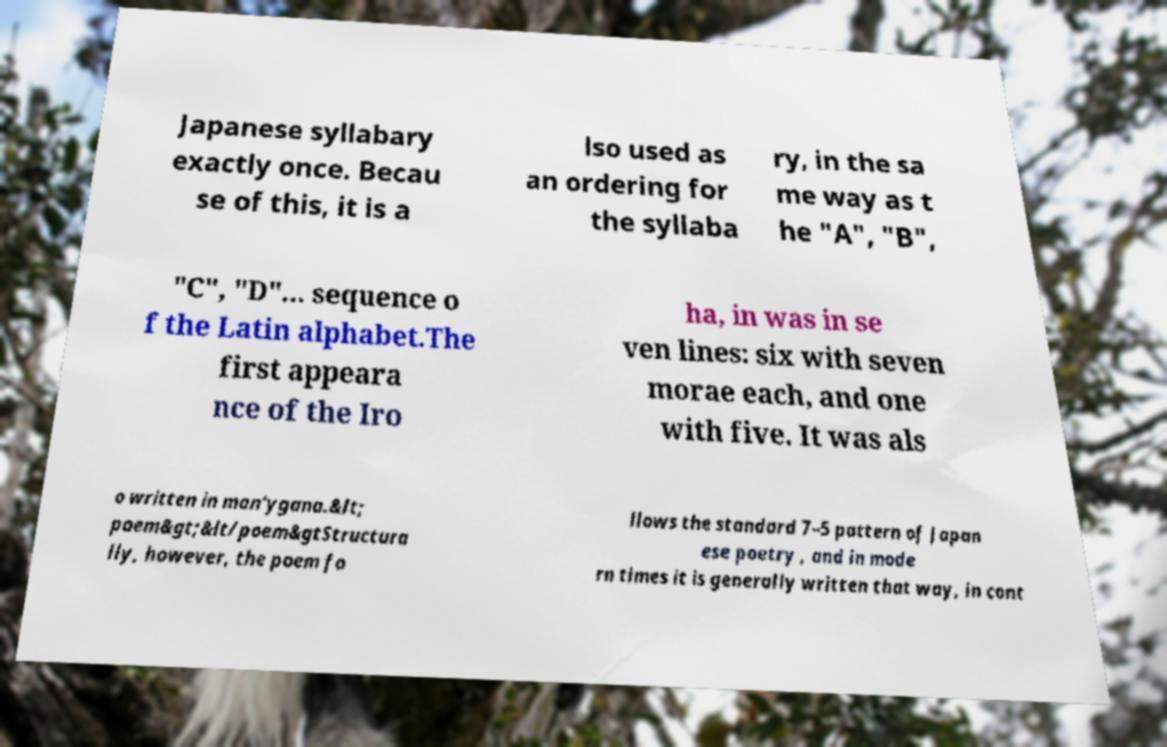Can you read and provide the text displayed in the image?This photo seems to have some interesting text. Can you extract and type it out for me? Japanese syllabary exactly once. Becau se of this, it is a lso used as an ordering for the syllaba ry, in the sa me way as t he "A", "B", "C", "D"... sequence o f the Latin alphabet.The first appeara nce of the Iro ha, in was in se ven lines: six with seven morae each, and one with five. It was als o written in man'ygana.&lt; poem&gt;&lt/poem&gtStructura lly, however, the poem fo llows the standard 7–5 pattern of Japan ese poetry , and in mode rn times it is generally written that way, in cont 